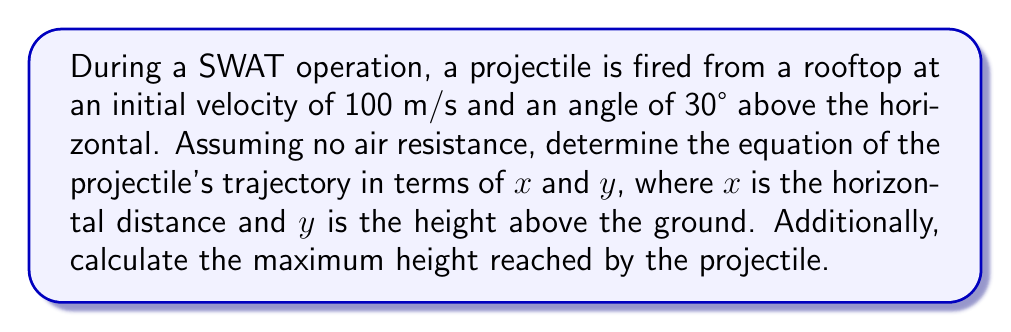What is the answer to this math problem? To solve this problem, we'll use the equations of motion for a projectile and derive the trajectory equation:

1. Decompose the initial velocity into x and y components:
   $v_{0x} = v_0 \cos \theta = 100 \cos 30° = 50\sqrt{3}$ m/s
   $v_{0y} = v_0 \sin \theta = 100 \sin 30° = 50$ m/s

2. The horizontal motion is uniform:
   $x = v_{0x}t = 50\sqrt{3}t$

3. The vertical motion is uniformly accelerated:
   $y = v_{0y}t - \frac{1}{2}gt^2$
   where $g = 9.8$ m/s²

4. Substitute the time $t$ from step 2 into the equation from step 3:
   $y = 50 \cdot \frac{x}{50\sqrt{3}} - \frac{1}{2} \cdot 9.8 \cdot (\frac{x}{50\sqrt{3}})^2$

5. Simplify the equation:
   $y = \frac{x}{\sqrt{3}} - \frac{9.8}{15000} x^2$

This is the equation of the projectile's trajectory.

To find the maximum height:

6. The maximum height occurs when $v_y = 0$:
   $0 = v_{0y} - gt$
   $t = \frac{v_{0y}}{g} = \frac{50}{9.8} = 5.10$ seconds

7. Substitute this time into the vertical motion equation:
   $y_{max} = v_{0y}t - \frac{1}{2}gt^2$
   $y_{max} = 50 \cdot 5.10 - \frac{1}{2} \cdot 9.8 \cdot 5.10^2$
   $y_{max} = 255 - 127.5 = 127.5$ meters
Answer: Trajectory equation: $y = \frac{x}{\sqrt{3}} - \frac{9.8}{15000} x^2$; Maximum height: 127.5 m 